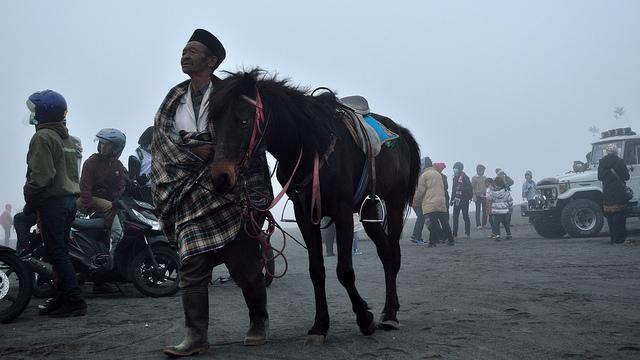How many horses are in this picture?
Give a very brief answer. 1. How many horses in this photo?
Give a very brief answer. 1. How many blue cars are in the background?
Give a very brief answer. 0. How many of the goats are standing?
Give a very brief answer. 0. How many people on horses?
Give a very brief answer. 0. How many people are in the photo?
Give a very brief answer. 5. 